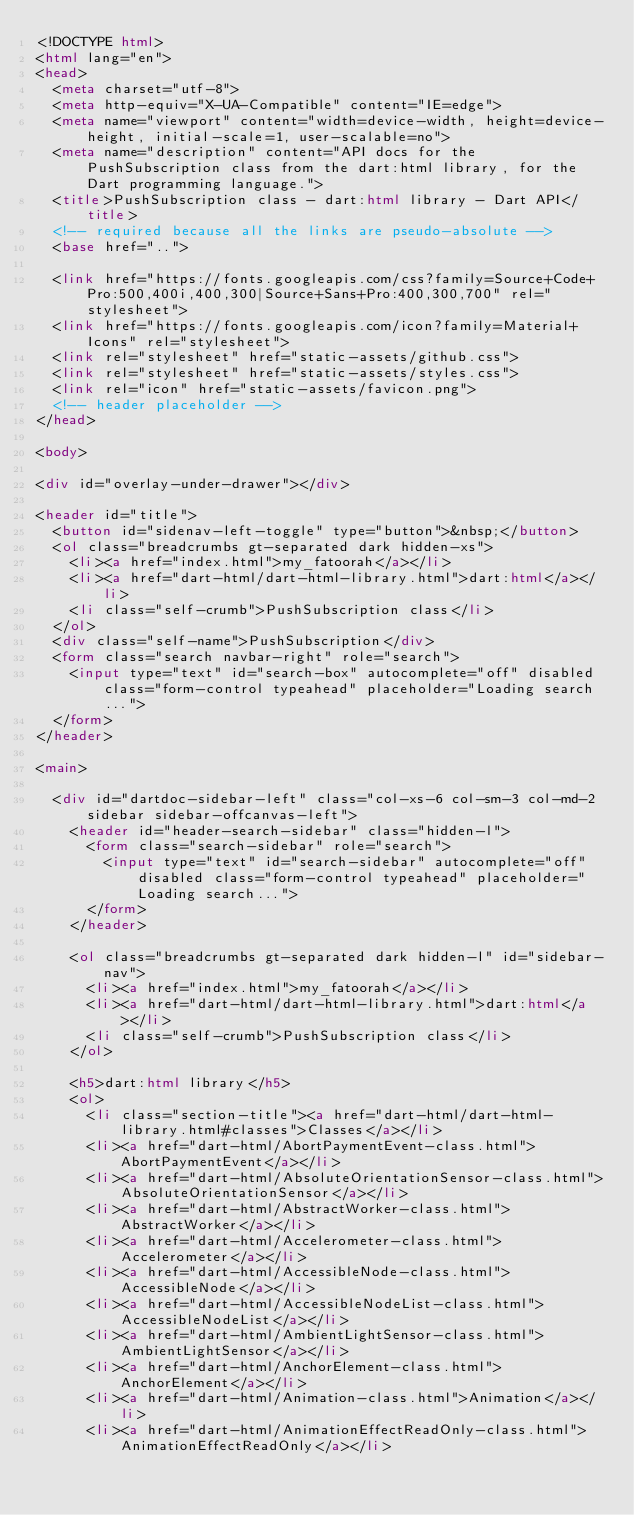Convert code to text. <code><loc_0><loc_0><loc_500><loc_500><_HTML_><!DOCTYPE html>
<html lang="en">
<head>
  <meta charset="utf-8">
  <meta http-equiv="X-UA-Compatible" content="IE=edge">
  <meta name="viewport" content="width=device-width, height=device-height, initial-scale=1, user-scalable=no">
  <meta name="description" content="API docs for the PushSubscription class from the dart:html library, for the Dart programming language.">
  <title>PushSubscription class - dart:html library - Dart API</title>
  <!-- required because all the links are pseudo-absolute -->
  <base href="..">

  <link href="https://fonts.googleapis.com/css?family=Source+Code+Pro:500,400i,400,300|Source+Sans+Pro:400,300,700" rel="stylesheet">
  <link href="https://fonts.googleapis.com/icon?family=Material+Icons" rel="stylesheet">
  <link rel="stylesheet" href="static-assets/github.css">
  <link rel="stylesheet" href="static-assets/styles.css">
  <link rel="icon" href="static-assets/favicon.png">
  <!-- header placeholder -->
</head>

<body>

<div id="overlay-under-drawer"></div>

<header id="title">
  <button id="sidenav-left-toggle" type="button">&nbsp;</button>
  <ol class="breadcrumbs gt-separated dark hidden-xs">
    <li><a href="index.html">my_fatoorah</a></li>
    <li><a href="dart-html/dart-html-library.html">dart:html</a></li>
    <li class="self-crumb">PushSubscription class</li>
  </ol>
  <div class="self-name">PushSubscription</div>
  <form class="search navbar-right" role="search">
    <input type="text" id="search-box" autocomplete="off" disabled class="form-control typeahead" placeholder="Loading search...">
  </form>
</header>

<main>

  <div id="dartdoc-sidebar-left" class="col-xs-6 col-sm-3 col-md-2 sidebar sidebar-offcanvas-left">
    <header id="header-search-sidebar" class="hidden-l">
      <form class="search-sidebar" role="search">
        <input type="text" id="search-sidebar" autocomplete="off" disabled class="form-control typeahead" placeholder="Loading search...">
      </form>
    </header>
    
    <ol class="breadcrumbs gt-separated dark hidden-l" id="sidebar-nav">
      <li><a href="index.html">my_fatoorah</a></li>
      <li><a href="dart-html/dart-html-library.html">dart:html</a></li>
      <li class="self-crumb">PushSubscription class</li>
    </ol>
    
    <h5>dart:html library</h5>
    <ol>
      <li class="section-title"><a href="dart-html/dart-html-library.html#classes">Classes</a></li>
      <li><a href="dart-html/AbortPaymentEvent-class.html">AbortPaymentEvent</a></li>
      <li><a href="dart-html/AbsoluteOrientationSensor-class.html">AbsoluteOrientationSensor</a></li>
      <li><a href="dart-html/AbstractWorker-class.html">AbstractWorker</a></li>
      <li><a href="dart-html/Accelerometer-class.html">Accelerometer</a></li>
      <li><a href="dart-html/AccessibleNode-class.html">AccessibleNode</a></li>
      <li><a href="dart-html/AccessibleNodeList-class.html">AccessibleNodeList</a></li>
      <li><a href="dart-html/AmbientLightSensor-class.html">AmbientLightSensor</a></li>
      <li><a href="dart-html/AnchorElement-class.html">AnchorElement</a></li>
      <li><a href="dart-html/Animation-class.html">Animation</a></li>
      <li><a href="dart-html/AnimationEffectReadOnly-class.html">AnimationEffectReadOnly</a></li></code> 